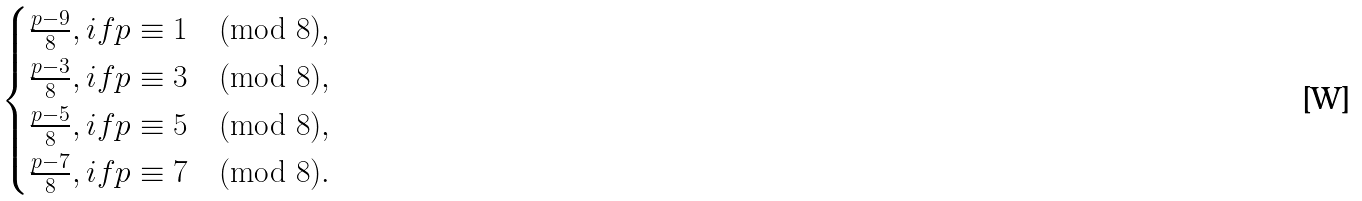<formula> <loc_0><loc_0><loc_500><loc_500>\begin{cases} \frac { p - 9 } { 8 } , i f p \equiv 1 \pmod { 8 } , \\ \frac { p - 3 } { 8 } , i f p \equiv 3 \pmod { 8 } , \\ \frac { p - 5 } { 8 } , i f p \equiv 5 \pmod { 8 } , \\ \frac { p - 7 } { 8 } , i f p \equiv 7 \pmod { 8 } . \\ \end{cases}</formula> 